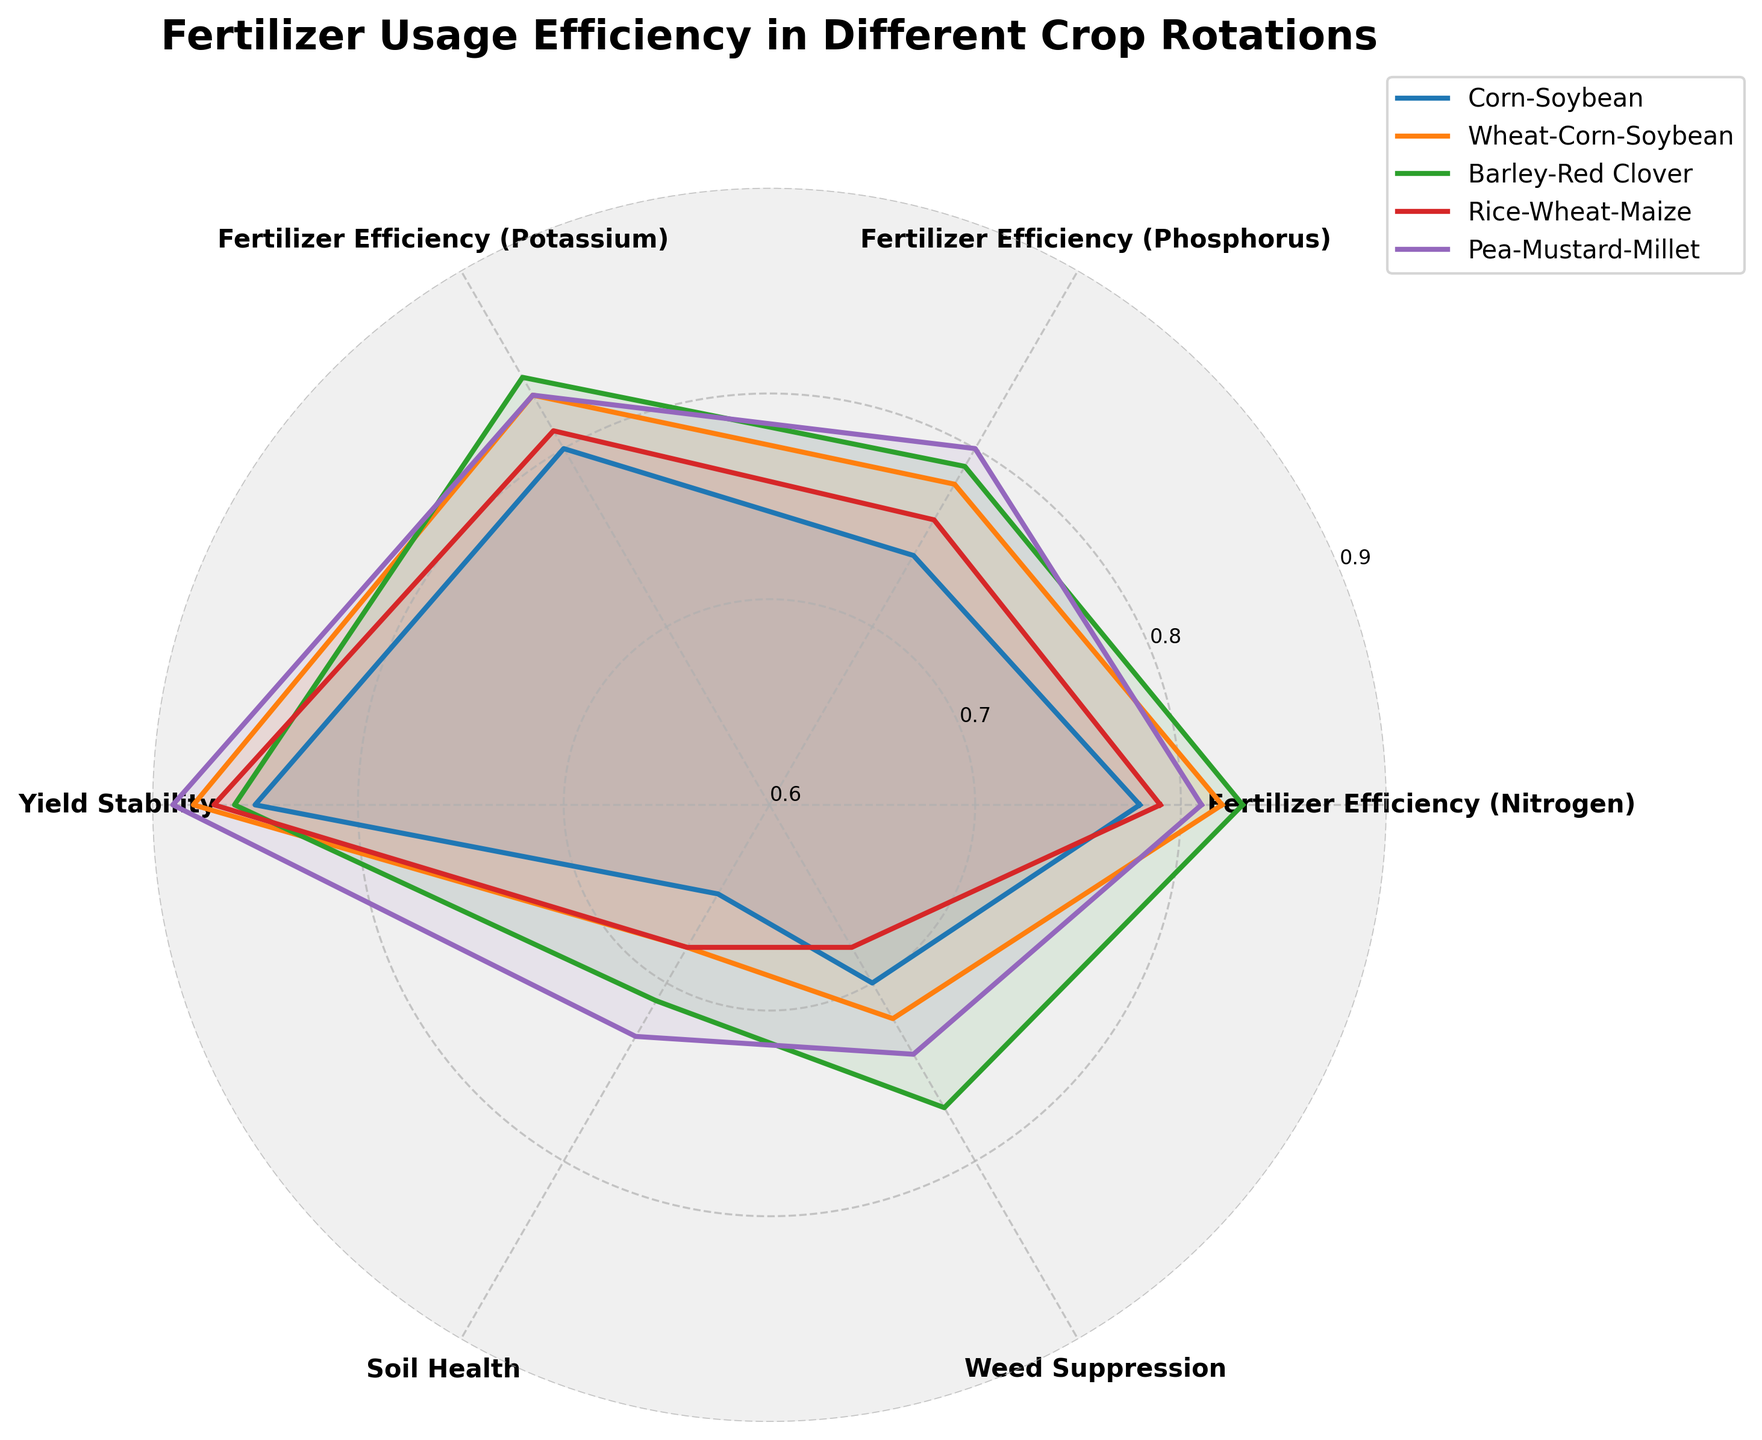What's the highest value for Fertilizer Efficiency (Nitrogen) across all crop rotations? The highest value for Fertilizer Efficiency (Nitrogen) can be found by looking at the outermost points on the radial axis labeled "Fertilizer Efficiency (Nitrogen)" on the radar chart. The highest value is 0.83, which corresponds to both Barley-Red Clover and Wheat-Corn-Soybean crops.
Answer: 0.83 What's the range of Yield Stability values among the crop rotations? The range is found by determining the minimum and maximum Yield Stability values, then subtracting the minimum from the maximum. The minimum Yield Stability on the chart is 0.85 (Corn-Soybean) and the maximum is 0.89 (Pea-Mustard-Millet). Therefore, the range is 0.89 - 0.85 = 0.04.
Answer: 0.04 Which crop rotation has the best Soil Health? The best Soil Health is represented by the highest point on the radial axis labeled "Soil Health." According to the radar chart, the highest value for Soil Health is 0.73, which corresponds to the Pea-Mustard-Millet crop rotation.
Answer: Pea-Mustard-Millet How does the Fertilizer Efficiency (Potassium) of Corn-Soybean compare to Wheat-Corn-Soybean? To compare these values, look at the points for Fertilizer Efficiency (Potassium) on the radar chart for both crop rotations. Corn-Soybean has a value of 0.80, while Wheat-Corn-Soybean has a value of 0.83. Wheat-Corn-Soybean has a higher Fertilizer Efficiency (Potassium) than Corn-Soybean.
Answer: Wheat-Corn-Soybean is higher What's the average value of Weed Suppression for all crop rotations? The average Weed Suppression value is calculated by summing all Weed Suppression values and dividing by the number of crop rotations. The values are 0.70, 0.72, 0.77, 0.68, and 0.74. Sum: 0.70 + 0.72 + 0.77 + 0.68 + 0.74 = 3.61. Average: 3.61 / 5 = 0.722.
Answer: 0.72 Which crop rotation has the most stable yield? The most stable yield corresponds to the highest point on the radial axis labeled "Yield Stability." According to the chart, the highest Yield Stability value is 0.89, which is attributed to the Pea-Mustard-Millet crop rotation.
Answer: Pea-Mustard-Millet Compare the Soil Health between Barley-Red Clover and Rice-Wheat-Maize crop rotations. Which one is better? To compare Soil Health, look at the data points for "Soil Health" on the radar chart. Barley-Red Clover has a Soil Health value of 0.71, while Rice-Wheat-Maize has a value of 0.68. Barley-Red Clover has better Soil Health.
Answer: Barley-Red Clover What's the difference in Phosphorus Efficiency between the lowest and highest crop rotations? Identify the Phosphorus Efficiency extremes by looking at the radial plots. The lowest is Corn-Soybean with 0.74, and the highest is Pea-Mustard-Millet with 0.80. The difference is 0.80 - 0.74 = 0.06.
Answer: 0.06 Which attribute shows the biggest variation across different crop rotations? To determine the biggest variation, check the range for each attribute across all rotations. Soil Health varies from 0.65 (Corn-Soybean) to 0.73 (Pea-Mustard-Millet) giving a range of 0.08, which is the largest among all attributes.
Answer: Soil Health Of all the crop rotations, which one offers the best overall performance across all efficiency metrics? By examining the overall span of the radar chart, Pea-Mustard-Millet shows the most consistent high values across different metrics: highest Yield Stability (0.89), top Phosphorus Efficiency (0.80), and best Soil Health (0.73).
Answer: Pea-Mustard-Millet 